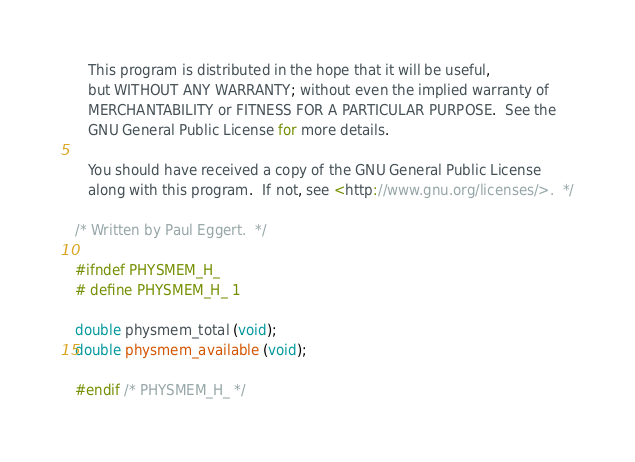<code> <loc_0><loc_0><loc_500><loc_500><_C_>
   This program is distributed in the hope that it will be useful,
   but WITHOUT ANY WARRANTY; without even the implied warranty of
   MERCHANTABILITY or FITNESS FOR A PARTICULAR PURPOSE.  See the
   GNU General Public License for more details.

   You should have received a copy of the GNU General Public License
   along with this program.  If not, see <http://www.gnu.org/licenses/>.  */

/* Written by Paul Eggert.  */

#ifndef PHYSMEM_H_
# define PHYSMEM_H_ 1

double physmem_total (void);
double physmem_available (void);

#endif /* PHYSMEM_H_ */
</code> 